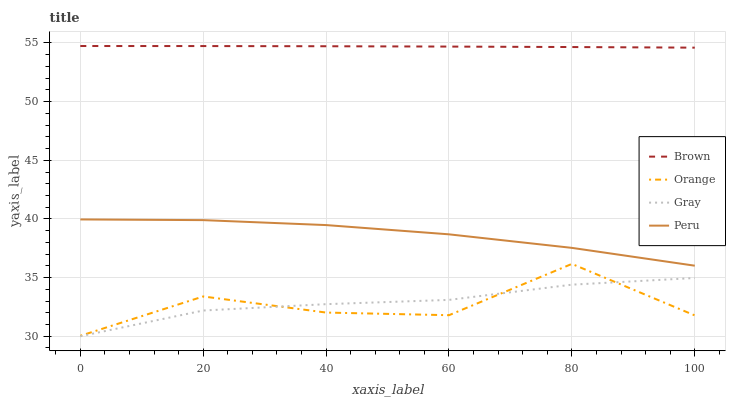Does Orange have the minimum area under the curve?
Answer yes or no. Yes. Does Brown have the maximum area under the curve?
Answer yes or no. Yes. Does Peru have the minimum area under the curve?
Answer yes or no. No. Does Peru have the maximum area under the curve?
Answer yes or no. No. Is Brown the smoothest?
Answer yes or no. Yes. Is Orange the roughest?
Answer yes or no. Yes. Is Peru the smoothest?
Answer yes or no. No. Is Peru the roughest?
Answer yes or no. No. Does Gray have the lowest value?
Answer yes or no. Yes. Does Peru have the lowest value?
Answer yes or no. No. Does Brown have the highest value?
Answer yes or no. Yes. Does Peru have the highest value?
Answer yes or no. No. Is Gray less than Peru?
Answer yes or no. Yes. Is Peru greater than Orange?
Answer yes or no. Yes. Does Gray intersect Orange?
Answer yes or no. Yes. Is Gray less than Orange?
Answer yes or no. No. Is Gray greater than Orange?
Answer yes or no. No. Does Gray intersect Peru?
Answer yes or no. No. 